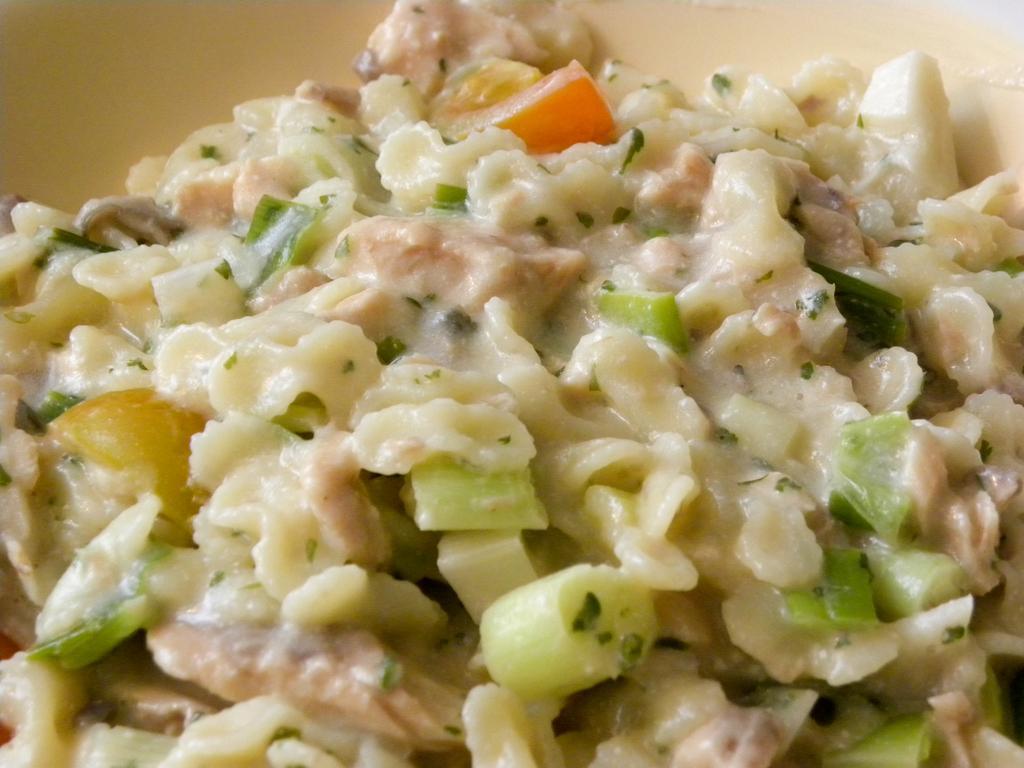Describe this image in one or two sentences. In this picture there is some food. 